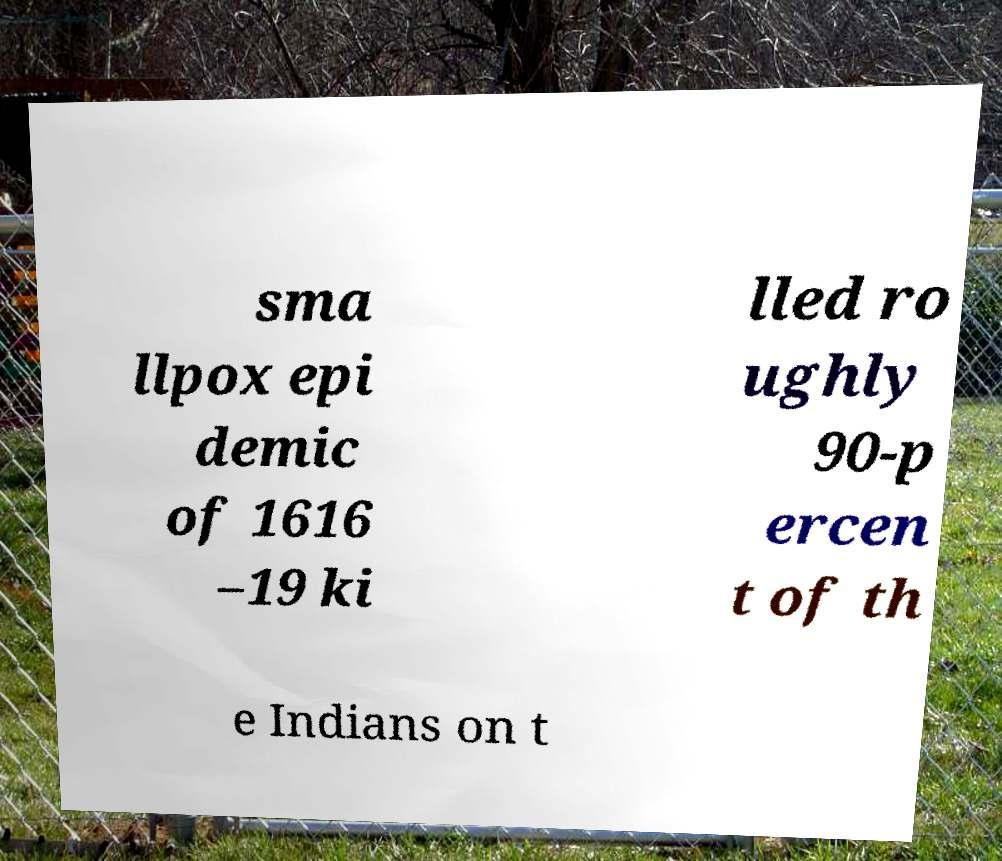There's text embedded in this image that I need extracted. Can you transcribe it verbatim? sma llpox epi demic of 1616 –19 ki lled ro ughly 90-p ercen t of th e Indians on t 